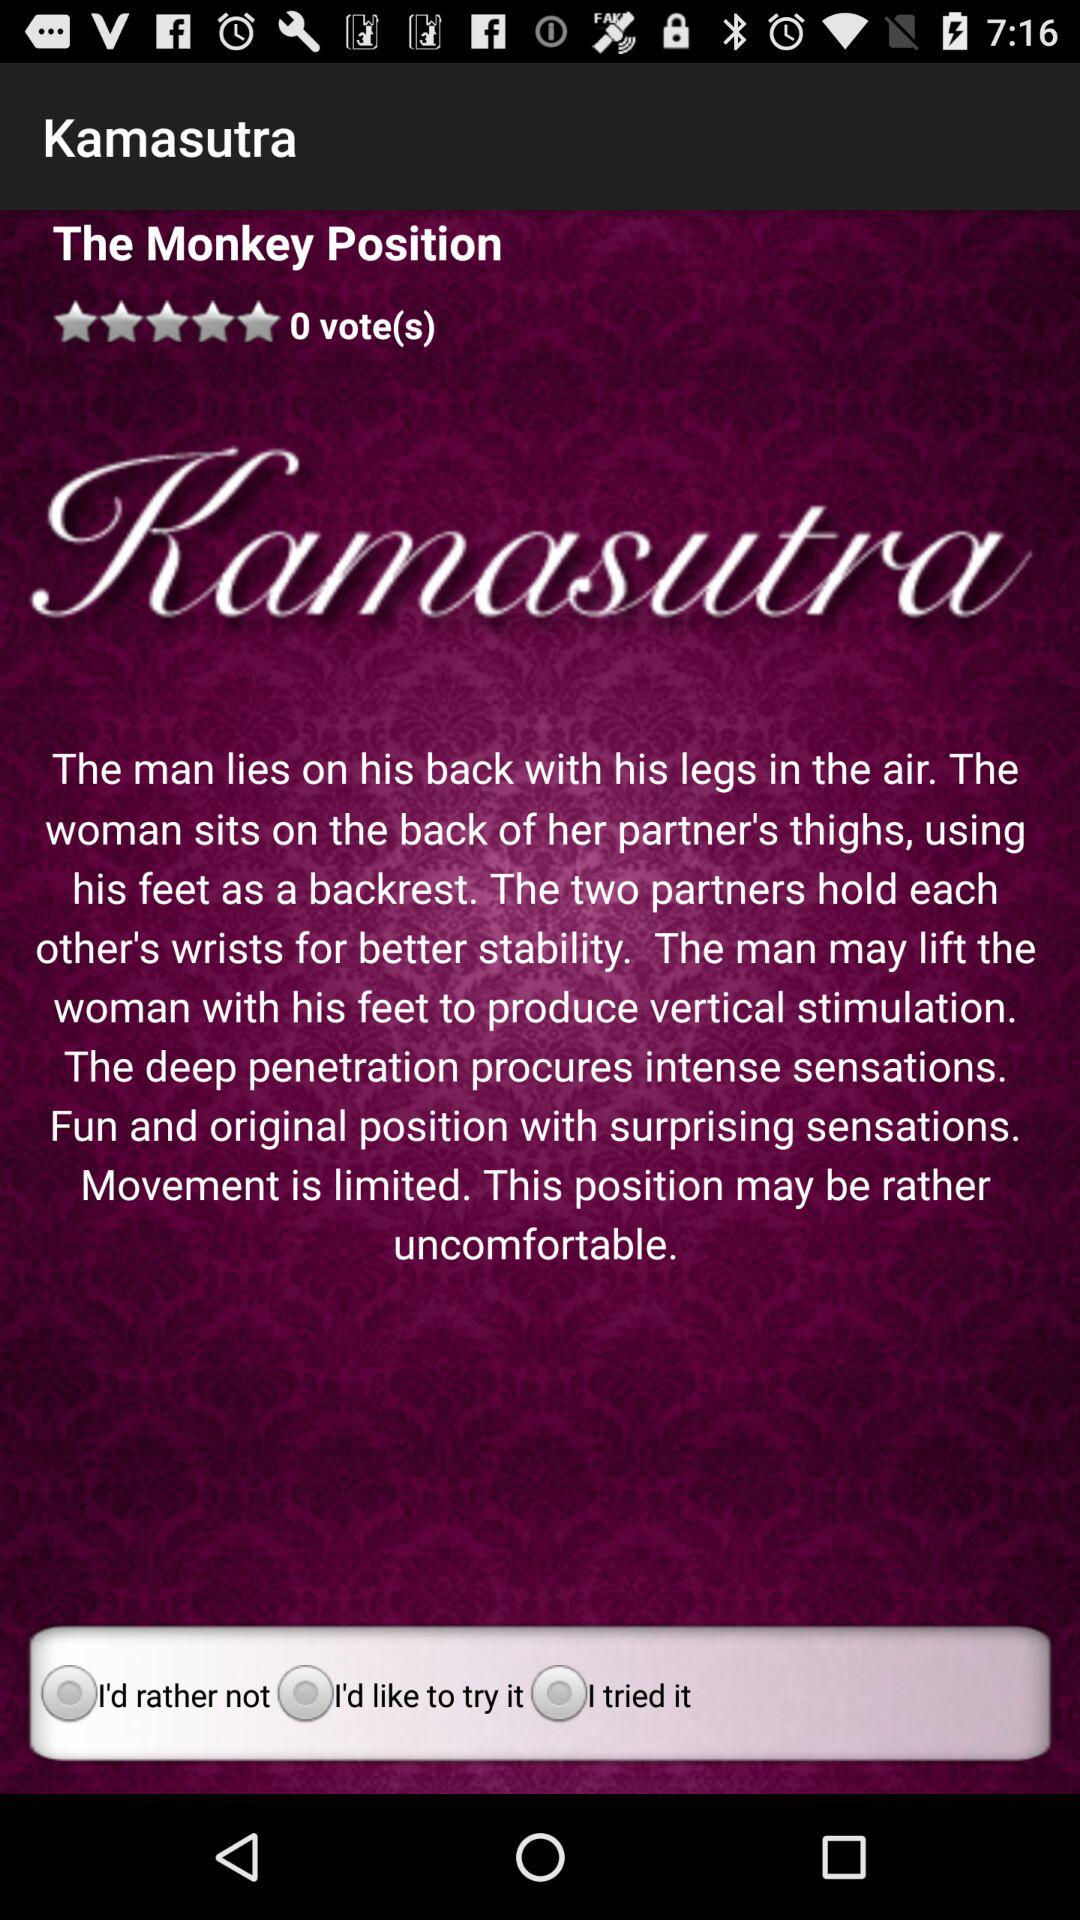How many people have tried this position?
Answer the question using a single word or phrase. 0 